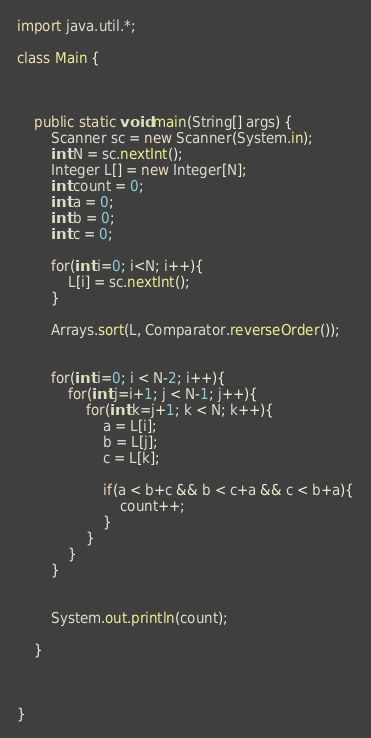<code> <loc_0><loc_0><loc_500><loc_500><_Java_>
import java.util.*;

class Main {



	public static void main(String[] args) {
        Scanner sc = new Scanner(System.in);
        int N = sc.nextInt();
        Integer L[] = new Integer[N];
        int count = 0;
        int a = 0;
        int b = 0;
        int c = 0;

        for(int i=0; i<N; i++){
            L[i] = sc.nextInt();
        }

        Arrays.sort(L, Comparator.reverseOrder());


        for(int i=0; i < N-2; i++){
            for(int j=i+1; j < N-1; j++){
                for(int k=j+1; k < N; k++){
                    a = L[i];
                    b = L[j];
                    c = L[k];

                    if(a < b+c && b < c+a && c < b+a){
                        count++;
                    }
                }
            }
        }


        System.out.println(count);

    }



}





</code> 